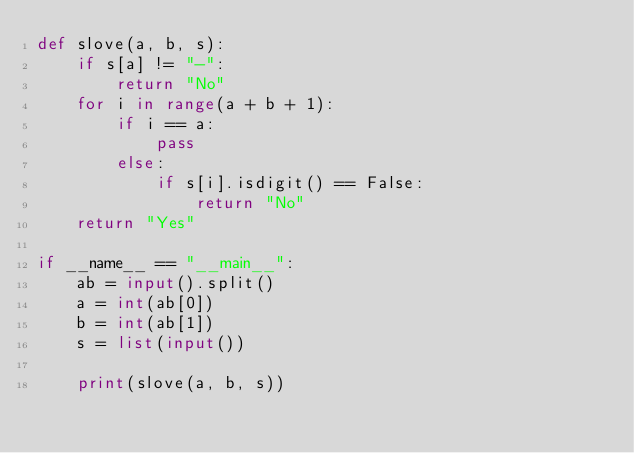<code> <loc_0><loc_0><loc_500><loc_500><_Python_>def slove(a, b, s):
    if s[a] != "-":
        return "No"
    for i in range(a + b + 1):
        if i == a:
            pass
        else:
            if s[i].isdigit() == False:
                return "No"
    return "Yes"

if __name__ == "__main__":
    ab = input().split()
    a = int(ab[0])
    b = int(ab[1])
    s = list(input())

    print(slove(a, b, s))</code> 